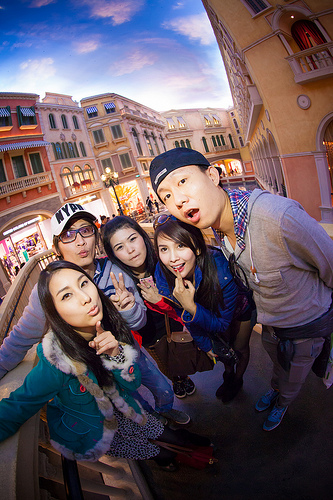<image>
Is the city behind the girl? Yes. From this viewpoint, the city is positioned behind the girl, with the girl partially or fully occluding the city. 